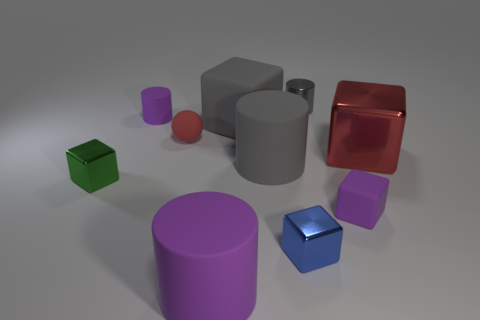Subtract all big gray cubes. How many cubes are left? 4 Subtract all gray cubes. Subtract all gray cylinders. How many cubes are left? 4 Subtract all big purple rubber objects. Subtract all purple rubber blocks. How many objects are left? 8 Add 7 tiny shiny cylinders. How many tiny shiny cylinders are left? 8 Add 9 large gray cylinders. How many large gray cylinders exist? 10 Subtract 0 blue cylinders. How many objects are left? 10 Subtract all balls. How many objects are left? 9 